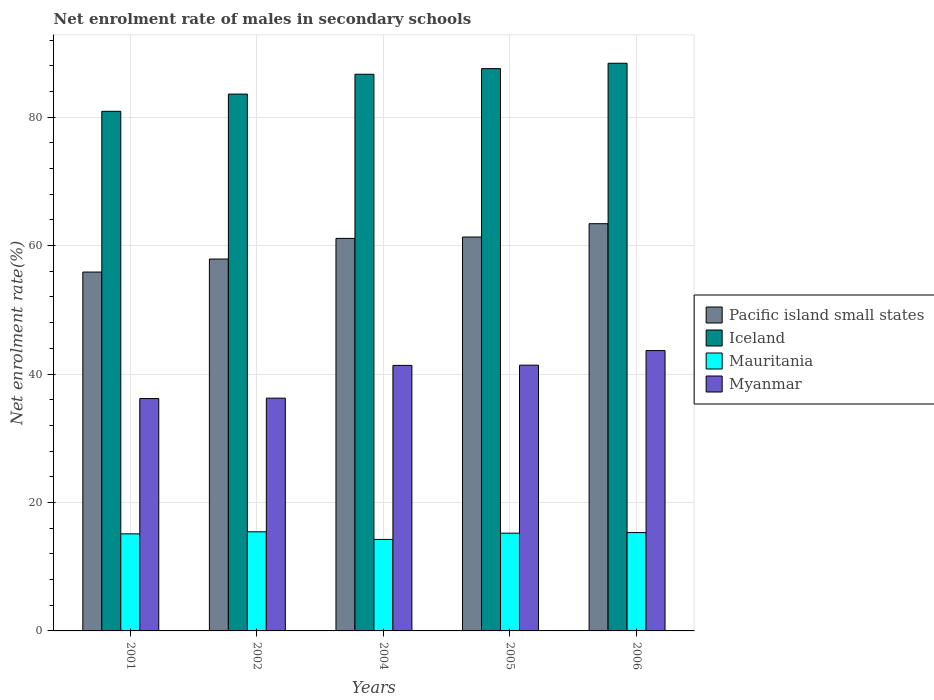How many groups of bars are there?
Provide a short and direct response. 5. How many bars are there on the 1st tick from the left?
Keep it short and to the point. 4. How many bars are there on the 1st tick from the right?
Offer a very short reply. 4. What is the label of the 2nd group of bars from the left?
Give a very brief answer. 2002. What is the net enrolment rate of males in secondary schools in Myanmar in 2005?
Ensure brevity in your answer.  41.38. Across all years, what is the maximum net enrolment rate of males in secondary schools in Mauritania?
Provide a succinct answer. 15.43. Across all years, what is the minimum net enrolment rate of males in secondary schools in Pacific island small states?
Keep it short and to the point. 55.88. In which year was the net enrolment rate of males in secondary schools in Myanmar maximum?
Offer a terse response. 2006. In which year was the net enrolment rate of males in secondary schools in Iceland minimum?
Offer a terse response. 2001. What is the total net enrolment rate of males in secondary schools in Pacific island small states in the graph?
Provide a short and direct response. 299.63. What is the difference between the net enrolment rate of males in secondary schools in Mauritania in 2001 and that in 2006?
Provide a short and direct response. -0.2. What is the difference between the net enrolment rate of males in secondary schools in Pacific island small states in 2005 and the net enrolment rate of males in secondary schools in Myanmar in 2002?
Give a very brief answer. 25.09. What is the average net enrolment rate of males in secondary schools in Pacific island small states per year?
Your answer should be compact. 59.93. In the year 2004, what is the difference between the net enrolment rate of males in secondary schools in Myanmar and net enrolment rate of males in secondary schools in Iceland?
Keep it short and to the point. -45.33. In how many years, is the net enrolment rate of males in secondary schools in Mauritania greater than 36 %?
Keep it short and to the point. 0. What is the ratio of the net enrolment rate of males in secondary schools in Myanmar in 2002 to that in 2005?
Offer a terse response. 0.88. Is the net enrolment rate of males in secondary schools in Myanmar in 2002 less than that in 2006?
Keep it short and to the point. Yes. Is the difference between the net enrolment rate of males in secondary schools in Myanmar in 2001 and 2006 greater than the difference between the net enrolment rate of males in secondary schools in Iceland in 2001 and 2006?
Your response must be concise. Yes. What is the difference between the highest and the second highest net enrolment rate of males in secondary schools in Mauritania?
Ensure brevity in your answer.  0.12. What is the difference between the highest and the lowest net enrolment rate of males in secondary schools in Mauritania?
Your answer should be compact. 1.19. In how many years, is the net enrolment rate of males in secondary schools in Pacific island small states greater than the average net enrolment rate of males in secondary schools in Pacific island small states taken over all years?
Provide a short and direct response. 3. What does the 2nd bar from the left in 2001 represents?
Keep it short and to the point. Iceland. What does the 3rd bar from the right in 2006 represents?
Your response must be concise. Iceland. Is it the case that in every year, the sum of the net enrolment rate of males in secondary schools in Mauritania and net enrolment rate of males in secondary schools in Iceland is greater than the net enrolment rate of males in secondary schools in Pacific island small states?
Your response must be concise. Yes. How many years are there in the graph?
Ensure brevity in your answer.  5. Does the graph contain any zero values?
Your answer should be compact. No. Where does the legend appear in the graph?
Provide a succinct answer. Center right. How many legend labels are there?
Offer a very short reply. 4. How are the legend labels stacked?
Ensure brevity in your answer.  Vertical. What is the title of the graph?
Keep it short and to the point. Net enrolment rate of males in secondary schools. Does "San Marino" appear as one of the legend labels in the graph?
Offer a terse response. No. What is the label or title of the Y-axis?
Make the answer very short. Net enrolment rate(%). What is the Net enrolment rate(%) of Pacific island small states in 2001?
Provide a succinct answer. 55.88. What is the Net enrolment rate(%) in Iceland in 2001?
Ensure brevity in your answer.  80.91. What is the Net enrolment rate(%) of Mauritania in 2001?
Provide a succinct answer. 15.11. What is the Net enrolment rate(%) in Myanmar in 2001?
Provide a short and direct response. 36.18. What is the Net enrolment rate(%) of Pacific island small states in 2002?
Your response must be concise. 57.9. What is the Net enrolment rate(%) in Iceland in 2002?
Provide a succinct answer. 83.59. What is the Net enrolment rate(%) in Mauritania in 2002?
Give a very brief answer. 15.43. What is the Net enrolment rate(%) of Myanmar in 2002?
Your answer should be compact. 36.24. What is the Net enrolment rate(%) of Pacific island small states in 2004?
Your response must be concise. 61.12. What is the Net enrolment rate(%) of Iceland in 2004?
Provide a short and direct response. 86.68. What is the Net enrolment rate(%) of Mauritania in 2004?
Give a very brief answer. 14.25. What is the Net enrolment rate(%) of Myanmar in 2004?
Your response must be concise. 41.34. What is the Net enrolment rate(%) of Pacific island small states in 2005?
Give a very brief answer. 61.33. What is the Net enrolment rate(%) in Iceland in 2005?
Keep it short and to the point. 87.55. What is the Net enrolment rate(%) in Mauritania in 2005?
Offer a very short reply. 15.22. What is the Net enrolment rate(%) of Myanmar in 2005?
Offer a very short reply. 41.38. What is the Net enrolment rate(%) in Pacific island small states in 2006?
Provide a succinct answer. 63.41. What is the Net enrolment rate(%) in Iceland in 2006?
Ensure brevity in your answer.  88.39. What is the Net enrolment rate(%) in Mauritania in 2006?
Keep it short and to the point. 15.31. What is the Net enrolment rate(%) in Myanmar in 2006?
Keep it short and to the point. 43.65. Across all years, what is the maximum Net enrolment rate(%) of Pacific island small states?
Your answer should be compact. 63.41. Across all years, what is the maximum Net enrolment rate(%) of Iceland?
Make the answer very short. 88.39. Across all years, what is the maximum Net enrolment rate(%) in Mauritania?
Give a very brief answer. 15.43. Across all years, what is the maximum Net enrolment rate(%) in Myanmar?
Offer a very short reply. 43.65. Across all years, what is the minimum Net enrolment rate(%) of Pacific island small states?
Provide a short and direct response. 55.88. Across all years, what is the minimum Net enrolment rate(%) of Iceland?
Offer a very short reply. 80.91. Across all years, what is the minimum Net enrolment rate(%) in Mauritania?
Offer a very short reply. 14.25. Across all years, what is the minimum Net enrolment rate(%) in Myanmar?
Your answer should be compact. 36.18. What is the total Net enrolment rate(%) in Pacific island small states in the graph?
Your answer should be very brief. 299.63. What is the total Net enrolment rate(%) of Iceland in the graph?
Give a very brief answer. 427.11. What is the total Net enrolment rate(%) of Mauritania in the graph?
Your response must be concise. 75.33. What is the total Net enrolment rate(%) in Myanmar in the graph?
Make the answer very short. 198.79. What is the difference between the Net enrolment rate(%) of Pacific island small states in 2001 and that in 2002?
Your answer should be very brief. -2.03. What is the difference between the Net enrolment rate(%) in Iceland in 2001 and that in 2002?
Provide a short and direct response. -2.68. What is the difference between the Net enrolment rate(%) in Mauritania in 2001 and that in 2002?
Provide a short and direct response. -0.32. What is the difference between the Net enrolment rate(%) of Myanmar in 2001 and that in 2002?
Give a very brief answer. -0.06. What is the difference between the Net enrolment rate(%) in Pacific island small states in 2001 and that in 2004?
Make the answer very short. -5.24. What is the difference between the Net enrolment rate(%) in Iceland in 2001 and that in 2004?
Your answer should be compact. -5.77. What is the difference between the Net enrolment rate(%) of Mauritania in 2001 and that in 2004?
Your answer should be compact. 0.87. What is the difference between the Net enrolment rate(%) in Myanmar in 2001 and that in 2004?
Make the answer very short. -5.16. What is the difference between the Net enrolment rate(%) of Pacific island small states in 2001 and that in 2005?
Your answer should be compact. -5.45. What is the difference between the Net enrolment rate(%) of Iceland in 2001 and that in 2005?
Offer a very short reply. -6.65. What is the difference between the Net enrolment rate(%) of Mauritania in 2001 and that in 2005?
Offer a terse response. -0.1. What is the difference between the Net enrolment rate(%) in Myanmar in 2001 and that in 2005?
Offer a very short reply. -5.2. What is the difference between the Net enrolment rate(%) of Pacific island small states in 2001 and that in 2006?
Give a very brief answer. -7.53. What is the difference between the Net enrolment rate(%) of Iceland in 2001 and that in 2006?
Ensure brevity in your answer.  -7.48. What is the difference between the Net enrolment rate(%) of Mauritania in 2001 and that in 2006?
Your answer should be compact. -0.2. What is the difference between the Net enrolment rate(%) of Myanmar in 2001 and that in 2006?
Make the answer very short. -7.47. What is the difference between the Net enrolment rate(%) of Pacific island small states in 2002 and that in 2004?
Offer a very short reply. -3.21. What is the difference between the Net enrolment rate(%) of Iceland in 2002 and that in 2004?
Give a very brief answer. -3.09. What is the difference between the Net enrolment rate(%) of Mauritania in 2002 and that in 2004?
Ensure brevity in your answer.  1.19. What is the difference between the Net enrolment rate(%) in Myanmar in 2002 and that in 2004?
Your answer should be compact. -5.1. What is the difference between the Net enrolment rate(%) of Pacific island small states in 2002 and that in 2005?
Provide a short and direct response. -3.43. What is the difference between the Net enrolment rate(%) in Iceland in 2002 and that in 2005?
Your answer should be very brief. -3.96. What is the difference between the Net enrolment rate(%) in Mauritania in 2002 and that in 2005?
Your response must be concise. 0.21. What is the difference between the Net enrolment rate(%) of Myanmar in 2002 and that in 2005?
Ensure brevity in your answer.  -5.13. What is the difference between the Net enrolment rate(%) of Pacific island small states in 2002 and that in 2006?
Give a very brief answer. -5.5. What is the difference between the Net enrolment rate(%) in Iceland in 2002 and that in 2006?
Provide a short and direct response. -4.8. What is the difference between the Net enrolment rate(%) of Mauritania in 2002 and that in 2006?
Provide a succinct answer. 0.12. What is the difference between the Net enrolment rate(%) of Myanmar in 2002 and that in 2006?
Provide a short and direct response. -7.41. What is the difference between the Net enrolment rate(%) in Pacific island small states in 2004 and that in 2005?
Provide a succinct answer. -0.21. What is the difference between the Net enrolment rate(%) in Iceland in 2004 and that in 2005?
Ensure brevity in your answer.  -0.88. What is the difference between the Net enrolment rate(%) in Mauritania in 2004 and that in 2005?
Provide a short and direct response. -0.97. What is the difference between the Net enrolment rate(%) in Myanmar in 2004 and that in 2005?
Provide a short and direct response. -0.04. What is the difference between the Net enrolment rate(%) of Pacific island small states in 2004 and that in 2006?
Give a very brief answer. -2.29. What is the difference between the Net enrolment rate(%) in Iceland in 2004 and that in 2006?
Make the answer very short. -1.71. What is the difference between the Net enrolment rate(%) of Mauritania in 2004 and that in 2006?
Your response must be concise. -1.07. What is the difference between the Net enrolment rate(%) in Myanmar in 2004 and that in 2006?
Offer a very short reply. -2.31. What is the difference between the Net enrolment rate(%) in Pacific island small states in 2005 and that in 2006?
Offer a terse response. -2.08. What is the difference between the Net enrolment rate(%) of Iceland in 2005 and that in 2006?
Offer a very short reply. -0.83. What is the difference between the Net enrolment rate(%) in Mauritania in 2005 and that in 2006?
Make the answer very short. -0.1. What is the difference between the Net enrolment rate(%) in Myanmar in 2005 and that in 2006?
Provide a succinct answer. -2.27. What is the difference between the Net enrolment rate(%) in Pacific island small states in 2001 and the Net enrolment rate(%) in Iceland in 2002?
Give a very brief answer. -27.71. What is the difference between the Net enrolment rate(%) of Pacific island small states in 2001 and the Net enrolment rate(%) of Mauritania in 2002?
Your response must be concise. 40.44. What is the difference between the Net enrolment rate(%) in Pacific island small states in 2001 and the Net enrolment rate(%) in Myanmar in 2002?
Offer a terse response. 19.63. What is the difference between the Net enrolment rate(%) of Iceland in 2001 and the Net enrolment rate(%) of Mauritania in 2002?
Give a very brief answer. 65.47. What is the difference between the Net enrolment rate(%) in Iceland in 2001 and the Net enrolment rate(%) in Myanmar in 2002?
Provide a succinct answer. 44.66. What is the difference between the Net enrolment rate(%) in Mauritania in 2001 and the Net enrolment rate(%) in Myanmar in 2002?
Keep it short and to the point. -21.13. What is the difference between the Net enrolment rate(%) of Pacific island small states in 2001 and the Net enrolment rate(%) of Iceland in 2004?
Provide a succinct answer. -30.8. What is the difference between the Net enrolment rate(%) of Pacific island small states in 2001 and the Net enrolment rate(%) of Mauritania in 2004?
Your answer should be compact. 41.63. What is the difference between the Net enrolment rate(%) of Pacific island small states in 2001 and the Net enrolment rate(%) of Myanmar in 2004?
Make the answer very short. 14.53. What is the difference between the Net enrolment rate(%) in Iceland in 2001 and the Net enrolment rate(%) in Mauritania in 2004?
Give a very brief answer. 66.66. What is the difference between the Net enrolment rate(%) of Iceland in 2001 and the Net enrolment rate(%) of Myanmar in 2004?
Provide a short and direct response. 39.56. What is the difference between the Net enrolment rate(%) in Mauritania in 2001 and the Net enrolment rate(%) in Myanmar in 2004?
Offer a terse response. -26.23. What is the difference between the Net enrolment rate(%) in Pacific island small states in 2001 and the Net enrolment rate(%) in Iceland in 2005?
Offer a very short reply. -31.68. What is the difference between the Net enrolment rate(%) in Pacific island small states in 2001 and the Net enrolment rate(%) in Mauritania in 2005?
Your response must be concise. 40.66. What is the difference between the Net enrolment rate(%) of Pacific island small states in 2001 and the Net enrolment rate(%) of Myanmar in 2005?
Provide a succinct answer. 14.5. What is the difference between the Net enrolment rate(%) in Iceland in 2001 and the Net enrolment rate(%) in Mauritania in 2005?
Provide a short and direct response. 65.69. What is the difference between the Net enrolment rate(%) of Iceland in 2001 and the Net enrolment rate(%) of Myanmar in 2005?
Give a very brief answer. 39.53. What is the difference between the Net enrolment rate(%) of Mauritania in 2001 and the Net enrolment rate(%) of Myanmar in 2005?
Provide a succinct answer. -26.26. What is the difference between the Net enrolment rate(%) in Pacific island small states in 2001 and the Net enrolment rate(%) in Iceland in 2006?
Offer a very short reply. -32.51. What is the difference between the Net enrolment rate(%) of Pacific island small states in 2001 and the Net enrolment rate(%) of Mauritania in 2006?
Ensure brevity in your answer.  40.56. What is the difference between the Net enrolment rate(%) in Pacific island small states in 2001 and the Net enrolment rate(%) in Myanmar in 2006?
Ensure brevity in your answer.  12.23. What is the difference between the Net enrolment rate(%) in Iceland in 2001 and the Net enrolment rate(%) in Mauritania in 2006?
Offer a terse response. 65.59. What is the difference between the Net enrolment rate(%) of Iceland in 2001 and the Net enrolment rate(%) of Myanmar in 2006?
Provide a succinct answer. 37.26. What is the difference between the Net enrolment rate(%) in Mauritania in 2001 and the Net enrolment rate(%) in Myanmar in 2006?
Make the answer very short. -28.53. What is the difference between the Net enrolment rate(%) in Pacific island small states in 2002 and the Net enrolment rate(%) in Iceland in 2004?
Your answer should be compact. -28.77. What is the difference between the Net enrolment rate(%) of Pacific island small states in 2002 and the Net enrolment rate(%) of Mauritania in 2004?
Ensure brevity in your answer.  43.66. What is the difference between the Net enrolment rate(%) of Pacific island small states in 2002 and the Net enrolment rate(%) of Myanmar in 2004?
Ensure brevity in your answer.  16.56. What is the difference between the Net enrolment rate(%) of Iceland in 2002 and the Net enrolment rate(%) of Mauritania in 2004?
Your answer should be very brief. 69.34. What is the difference between the Net enrolment rate(%) of Iceland in 2002 and the Net enrolment rate(%) of Myanmar in 2004?
Make the answer very short. 42.25. What is the difference between the Net enrolment rate(%) of Mauritania in 2002 and the Net enrolment rate(%) of Myanmar in 2004?
Your response must be concise. -25.91. What is the difference between the Net enrolment rate(%) in Pacific island small states in 2002 and the Net enrolment rate(%) in Iceland in 2005?
Keep it short and to the point. -29.65. What is the difference between the Net enrolment rate(%) in Pacific island small states in 2002 and the Net enrolment rate(%) in Mauritania in 2005?
Your response must be concise. 42.68. What is the difference between the Net enrolment rate(%) in Pacific island small states in 2002 and the Net enrolment rate(%) in Myanmar in 2005?
Give a very brief answer. 16.52. What is the difference between the Net enrolment rate(%) in Iceland in 2002 and the Net enrolment rate(%) in Mauritania in 2005?
Provide a short and direct response. 68.37. What is the difference between the Net enrolment rate(%) of Iceland in 2002 and the Net enrolment rate(%) of Myanmar in 2005?
Offer a very short reply. 42.21. What is the difference between the Net enrolment rate(%) in Mauritania in 2002 and the Net enrolment rate(%) in Myanmar in 2005?
Give a very brief answer. -25.94. What is the difference between the Net enrolment rate(%) in Pacific island small states in 2002 and the Net enrolment rate(%) in Iceland in 2006?
Make the answer very short. -30.48. What is the difference between the Net enrolment rate(%) of Pacific island small states in 2002 and the Net enrolment rate(%) of Mauritania in 2006?
Ensure brevity in your answer.  42.59. What is the difference between the Net enrolment rate(%) in Pacific island small states in 2002 and the Net enrolment rate(%) in Myanmar in 2006?
Give a very brief answer. 14.25. What is the difference between the Net enrolment rate(%) in Iceland in 2002 and the Net enrolment rate(%) in Mauritania in 2006?
Keep it short and to the point. 68.27. What is the difference between the Net enrolment rate(%) of Iceland in 2002 and the Net enrolment rate(%) of Myanmar in 2006?
Make the answer very short. 39.94. What is the difference between the Net enrolment rate(%) of Mauritania in 2002 and the Net enrolment rate(%) of Myanmar in 2006?
Keep it short and to the point. -28.21. What is the difference between the Net enrolment rate(%) in Pacific island small states in 2004 and the Net enrolment rate(%) in Iceland in 2005?
Offer a very short reply. -26.43. What is the difference between the Net enrolment rate(%) of Pacific island small states in 2004 and the Net enrolment rate(%) of Mauritania in 2005?
Make the answer very short. 45.9. What is the difference between the Net enrolment rate(%) in Pacific island small states in 2004 and the Net enrolment rate(%) in Myanmar in 2005?
Give a very brief answer. 19.74. What is the difference between the Net enrolment rate(%) of Iceland in 2004 and the Net enrolment rate(%) of Mauritania in 2005?
Offer a very short reply. 71.46. What is the difference between the Net enrolment rate(%) of Iceland in 2004 and the Net enrolment rate(%) of Myanmar in 2005?
Offer a very short reply. 45.3. What is the difference between the Net enrolment rate(%) of Mauritania in 2004 and the Net enrolment rate(%) of Myanmar in 2005?
Keep it short and to the point. -27.13. What is the difference between the Net enrolment rate(%) in Pacific island small states in 2004 and the Net enrolment rate(%) in Iceland in 2006?
Provide a succinct answer. -27.27. What is the difference between the Net enrolment rate(%) of Pacific island small states in 2004 and the Net enrolment rate(%) of Mauritania in 2006?
Provide a succinct answer. 45.8. What is the difference between the Net enrolment rate(%) of Pacific island small states in 2004 and the Net enrolment rate(%) of Myanmar in 2006?
Keep it short and to the point. 17.47. What is the difference between the Net enrolment rate(%) in Iceland in 2004 and the Net enrolment rate(%) in Mauritania in 2006?
Make the answer very short. 71.36. What is the difference between the Net enrolment rate(%) of Iceland in 2004 and the Net enrolment rate(%) of Myanmar in 2006?
Make the answer very short. 43.03. What is the difference between the Net enrolment rate(%) in Mauritania in 2004 and the Net enrolment rate(%) in Myanmar in 2006?
Offer a very short reply. -29.4. What is the difference between the Net enrolment rate(%) in Pacific island small states in 2005 and the Net enrolment rate(%) in Iceland in 2006?
Ensure brevity in your answer.  -27.06. What is the difference between the Net enrolment rate(%) in Pacific island small states in 2005 and the Net enrolment rate(%) in Mauritania in 2006?
Make the answer very short. 46.01. What is the difference between the Net enrolment rate(%) of Pacific island small states in 2005 and the Net enrolment rate(%) of Myanmar in 2006?
Ensure brevity in your answer.  17.68. What is the difference between the Net enrolment rate(%) of Iceland in 2005 and the Net enrolment rate(%) of Mauritania in 2006?
Provide a short and direct response. 72.24. What is the difference between the Net enrolment rate(%) in Iceland in 2005 and the Net enrolment rate(%) in Myanmar in 2006?
Offer a terse response. 43.9. What is the difference between the Net enrolment rate(%) of Mauritania in 2005 and the Net enrolment rate(%) of Myanmar in 2006?
Your answer should be compact. -28.43. What is the average Net enrolment rate(%) of Pacific island small states per year?
Your answer should be compact. 59.93. What is the average Net enrolment rate(%) of Iceland per year?
Your answer should be very brief. 85.42. What is the average Net enrolment rate(%) in Mauritania per year?
Provide a succinct answer. 15.07. What is the average Net enrolment rate(%) in Myanmar per year?
Offer a terse response. 39.76. In the year 2001, what is the difference between the Net enrolment rate(%) in Pacific island small states and Net enrolment rate(%) in Iceland?
Your answer should be compact. -25.03. In the year 2001, what is the difference between the Net enrolment rate(%) in Pacific island small states and Net enrolment rate(%) in Mauritania?
Your answer should be very brief. 40.76. In the year 2001, what is the difference between the Net enrolment rate(%) of Pacific island small states and Net enrolment rate(%) of Myanmar?
Your answer should be very brief. 19.7. In the year 2001, what is the difference between the Net enrolment rate(%) of Iceland and Net enrolment rate(%) of Mauritania?
Offer a terse response. 65.79. In the year 2001, what is the difference between the Net enrolment rate(%) of Iceland and Net enrolment rate(%) of Myanmar?
Provide a succinct answer. 44.73. In the year 2001, what is the difference between the Net enrolment rate(%) in Mauritania and Net enrolment rate(%) in Myanmar?
Provide a succinct answer. -21.06. In the year 2002, what is the difference between the Net enrolment rate(%) in Pacific island small states and Net enrolment rate(%) in Iceland?
Make the answer very short. -25.69. In the year 2002, what is the difference between the Net enrolment rate(%) of Pacific island small states and Net enrolment rate(%) of Mauritania?
Offer a terse response. 42.47. In the year 2002, what is the difference between the Net enrolment rate(%) of Pacific island small states and Net enrolment rate(%) of Myanmar?
Offer a terse response. 21.66. In the year 2002, what is the difference between the Net enrolment rate(%) of Iceland and Net enrolment rate(%) of Mauritania?
Provide a short and direct response. 68.16. In the year 2002, what is the difference between the Net enrolment rate(%) of Iceland and Net enrolment rate(%) of Myanmar?
Your answer should be compact. 47.35. In the year 2002, what is the difference between the Net enrolment rate(%) in Mauritania and Net enrolment rate(%) in Myanmar?
Your response must be concise. -20.81. In the year 2004, what is the difference between the Net enrolment rate(%) in Pacific island small states and Net enrolment rate(%) in Iceland?
Keep it short and to the point. -25.56. In the year 2004, what is the difference between the Net enrolment rate(%) of Pacific island small states and Net enrolment rate(%) of Mauritania?
Provide a short and direct response. 46.87. In the year 2004, what is the difference between the Net enrolment rate(%) in Pacific island small states and Net enrolment rate(%) in Myanmar?
Your response must be concise. 19.78. In the year 2004, what is the difference between the Net enrolment rate(%) of Iceland and Net enrolment rate(%) of Mauritania?
Make the answer very short. 72.43. In the year 2004, what is the difference between the Net enrolment rate(%) of Iceland and Net enrolment rate(%) of Myanmar?
Provide a succinct answer. 45.33. In the year 2004, what is the difference between the Net enrolment rate(%) in Mauritania and Net enrolment rate(%) in Myanmar?
Your answer should be compact. -27.1. In the year 2005, what is the difference between the Net enrolment rate(%) in Pacific island small states and Net enrolment rate(%) in Iceland?
Keep it short and to the point. -26.22. In the year 2005, what is the difference between the Net enrolment rate(%) in Pacific island small states and Net enrolment rate(%) in Mauritania?
Offer a very short reply. 46.11. In the year 2005, what is the difference between the Net enrolment rate(%) of Pacific island small states and Net enrolment rate(%) of Myanmar?
Keep it short and to the point. 19.95. In the year 2005, what is the difference between the Net enrolment rate(%) in Iceland and Net enrolment rate(%) in Mauritania?
Offer a terse response. 72.33. In the year 2005, what is the difference between the Net enrolment rate(%) in Iceland and Net enrolment rate(%) in Myanmar?
Your answer should be compact. 46.17. In the year 2005, what is the difference between the Net enrolment rate(%) in Mauritania and Net enrolment rate(%) in Myanmar?
Keep it short and to the point. -26.16. In the year 2006, what is the difference between the Net enrolment rate(%) of Pacific island small states and Net enrolment rate(%) of Iceland?
Offer a terse response. -24.98. In the year 2006, what is the difference between the Net enrolment rate(%) in Pacific island small states and Net enrolment rate(%) in Mauritania?
Your response must be concise. 48.09. In the year 2006, what is the difference between the Net enrolment rate(%) in Pacific island small states and Net enrolment rate(%) in Myanmar?
Offer a terse response. 19.76. In the year 2006, what is the difference between the Net enrolment rate(%) in Iceland and Net enrolment rate(%) in Mauritania?
Provide a short and direct response. 73.07. In the year 2006, what is the difference between the Net enrolment rate(%) in Iceland and Net enrolment rate(%) in Myanmar?
Offer a very short reply. 44.74. In the year 2006, what is the difference between the Net enrolment rate(%) of Mauritania and Net enrolment rate(%) of Myanmar?
Your response must be concise. -28.33. What is the ratio of the Net enrolment rate(%) in Iceland in 2001 to that in 2002?
Keep it short and to the point. 0.97. What is the ratio of the Net enrolment rate(%) of Mauritania in 2001 to that in 2002?
Make the answer very short. 0.98. What is the ratio of the Net enrolment rate(%) in Myanmar in 2001 to that in 2002?
Keep it short and to the point. 1. What is the ratio of the Net enrolment rate(%) of Pacific island small states in 2001 to that in 2004?
Provide a succinct answer. 0.91. What is the ratio of the Net enrolment rate(%) in Iceland in 2001 to that in 2004?
Offer a very short reply. 0.93. What is the ratio of the Net enrolment rate(%) of Mauritania in 2001 to that in 2004?
Your response must be concise. 1.06. What is the ratio of the Net enrolment rate(%) of Myanmar in 2001 to that in 2004?
Make the answer very short. 0.88. What is the ratio of the Net enrolment rate(%) of Pacific island small states in 2001 to that in 2005?
Provide a short and direct response. 0.91. What is the ratio of the Net enrolment rate(%) of Iceland in 2001 to that in 2005?
Make the answer very short. 0.92. What is the ratio of the Net enrolment rate(%) of Myanmar in 2001 to that in 2005?
Keep it short and to the point. 0.87. What is the ratio of the Net enrolment rate(%) in Pacific island small states in 2001 to that in 2006?
Your answer should be compact. 0.88. What is the ratio of the Net enrolment rate(%) of Iceland in 2001 to that in 2006?
Give a very brief answer. 0.92. What is the ratio of the Net enrolment rate(%) of Mauritania in 2001 to that in 2006?
Keep it short and to the point. 0.99. What is the ratio of the Net enrolment rate(%) in Myanmar in 2001 to that in 2006?
Offer a terse response. 0.83. What is the ratio of the Net enrolment rate(%) in Pacific island small states in 2002 to that in 2004?
Provide a short and direct response. 0.95. What is the ratio of the Net enrolment rate(%) in Iceland in 2002 to that in 2004?
Your response must be concise. 0.96. What is the ratio of the Net enrolment rate(%) of Myanmar in 2002 to that in 2004?
Give a very brief answer. 0.88. What is the ratio of the Net enrolment rate(%) of Pacific island small states in 2002 to that in 2005?
Provide a succinct answer. 0.94. What is the ratio of the Net enrolment rate(%) of Iceland in 2002 to that in 2005?
Offer a terse response. 0.95. What is the ratio of the Net enrolment rate(%) in Mauritania in 2002 to that in 2005?
Ensure brevity in your answer.  1.01. What is the ratio of the Net enrolment rate(%) in Myanmar in 2002 to that in 2005?
Give a very brief answer. 0.88. What is the ratio of the Net enrolment rate(%) of Pacific island small states in 2002 to that in 2006?
Your response must be concise. 0.91. What is the ratio of the Net enrolment rate(%) in Iceland in 2002 to that in 2006?
Your response must be concise. 0.95. What is the ratio of the Net enrolment rate(%) in Mauritania in 2002 to that in 2006?
Keep it short and to the point. 1.01. What is the ratio of the Net enrolment rate(%) of Myanmar in 2002 to that in 2006?
Offer a terse response. 0.83. What is the ratio of the Net enrolment rate(%) of Mauritania in 2004 to that in 2005?
Keep it short and to the point. 0.94. What is the ratio of the Net enrolment rate(%) of Pacific island small states in 2004 to that in 2006?
Your response must be concise. 0.96. What is the ratio of the Net enrolment rate(%) of Iceland in 2004 to that in 2006?
Make the answer very short. 0.98. What is the ratio of the Net enrolment rate(%) of Mauritania in 2004 to that in 2006?
Provide a succinct answer. 0.93. What is the ratio of the Net enrolment rate(%) of Myanmar in 2004 to that in 2006?
Provide a succinct answer. 0.95. What is the ratio of the Net enrolment rate(%) of Pacific island small states in 2005 to that in 2006?
Your response must be concise. 0.97. What is the ratio of the Net enrolment rate(%) in Iceland in 2005 to that in 2006?
Offer a very short reply. 0.99. What is the ratio of the Net enrolment rate(%) of Mauritania in 2005 to that in 2006?
Ensure brevity in your answer.  0.99. What is the ratio of the Net enrolment rate(%) in Myanmar in 2005 to that in 2006?
Give a very brief answer. 0.95. What is the difference between the highest and the second highest Net enrolment rate(%) of Pacific island small states?
Provide a short and direct response. 2.08. What is the difference between the highest and the second highest Net enrolment rate(%) of Iceland?
Offer a very short reply. 0.83. What is the difference between the highest and the second highest Net enrolment rate(%) in Mauritania?
Provide a short and direct response. 0.12. What is the difference between the highest and the second highest Net enrolment rate(%) in Myanmar?
Offer a terse response. 2.27. What is the difference between the highest and the lowest Net enrolment rate(%) of Pacific island small states?
Give a very brief answer. 7.53. What is the difference between the highest and the lowest Net enrolment rate(%) in Iceland?
Your answer should be very brief. 7.48. What is the difference between the highest and the lowest Net enrolment rate(%) in Mauritania?
Keep it short and to the point. 1.19. What is the difference between the highest and the lowest Net enrolment rate(%) of Myanmar?
Give a very brief answer. 7.47. 